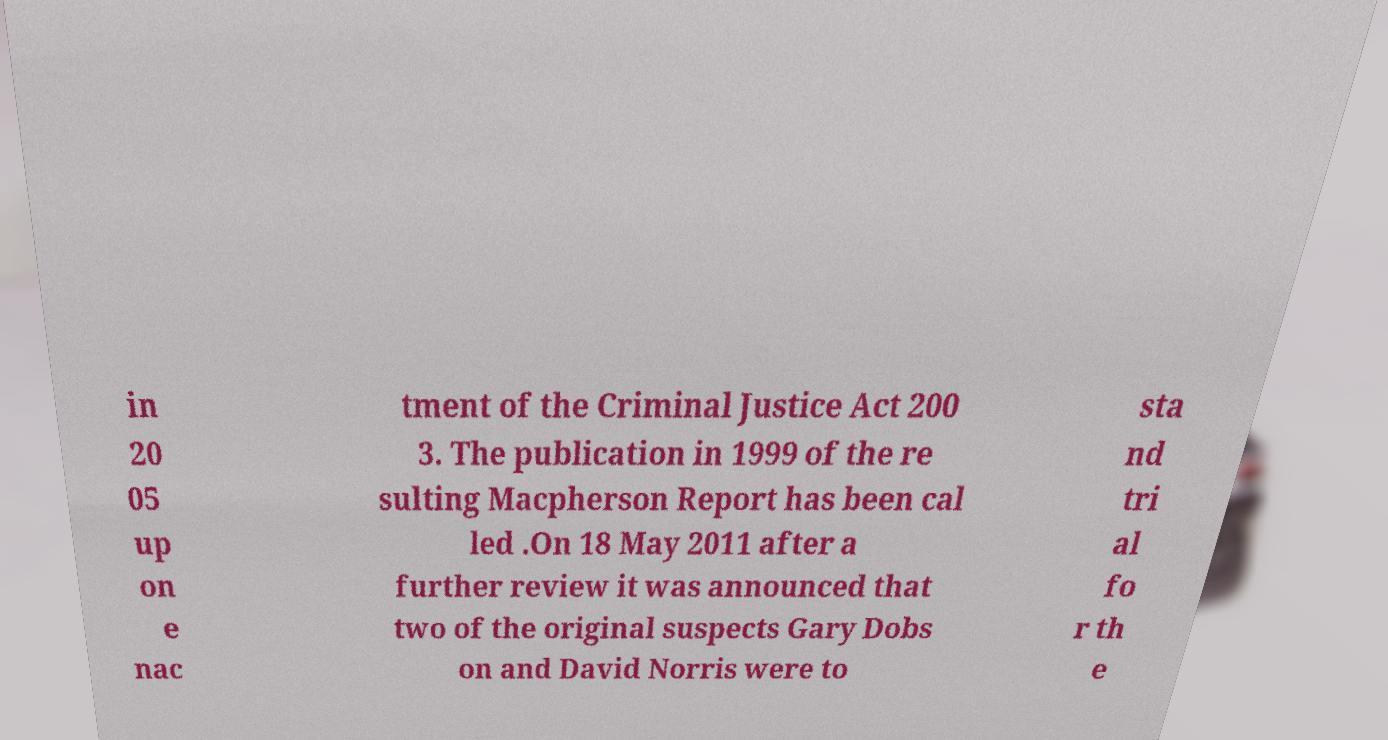Can you read and provide the text displayed in the image?This photo seems to have some interesting text. Can you extract and type it out for me? in 20 05 up on e nac tment of the Criminal Justice Act 200 3. The publication in 1999 of the re sulting Macpherson Report has been cal led .On 18 May 2011 after a further review it was announced that two of the original suspects Gary Dobs on and David Norris were to sta nd tri al fo r th e 